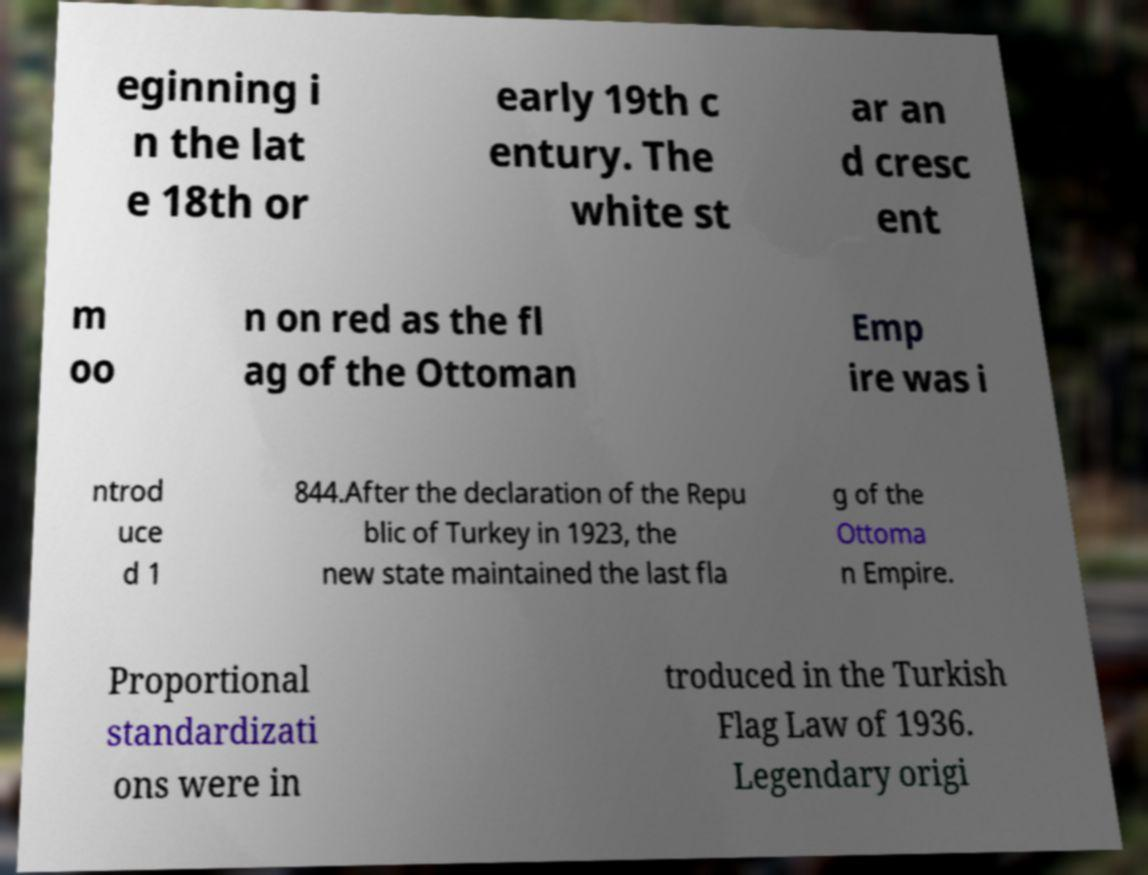Can you accurately transcribe the text from the provided image for me? eginning i n the lat e 18th or early 19th c entury. The white st ar an d cresc ent m oo n on red as the fl ag of the Ottoman Emp ire was i ntrod uce d 1 844.After the declaration of the Repu blic of Turkey in 1923, the new state maintained the last fla g of the Ottoma n Empire. Proportional standardizati ons were in troduced in the Turkish Flag Law of 1936. Legendary origi 